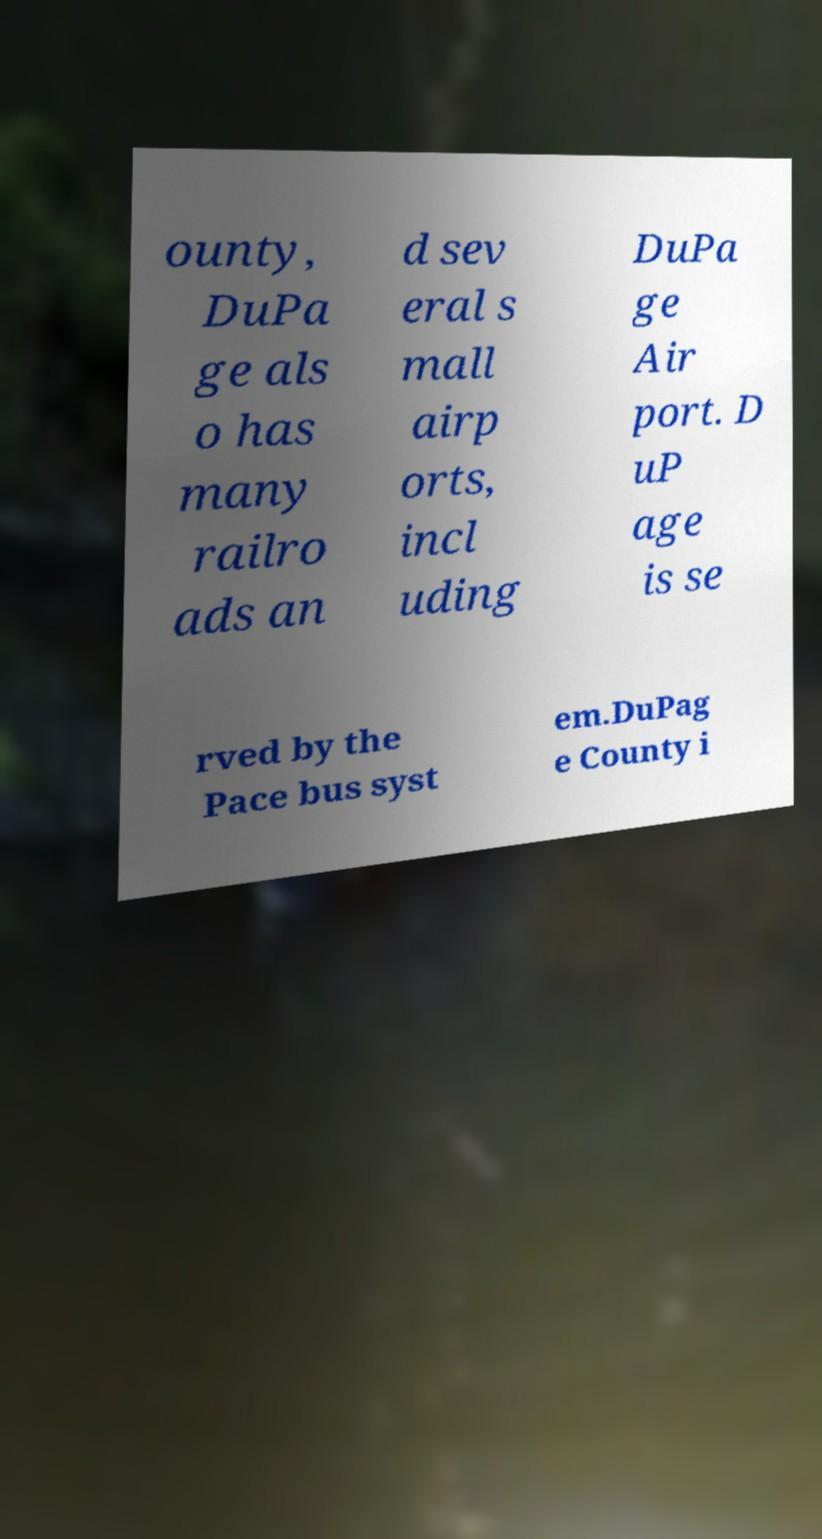Please read and relay the text visible in this image. What does it say? ounty, DuPa ge als o has many railro ads an d sev eral s mall airp orts, incl uding DuPa ge Air port. D uP age is se rved by the Pace bus syst em.DuPag e County i 